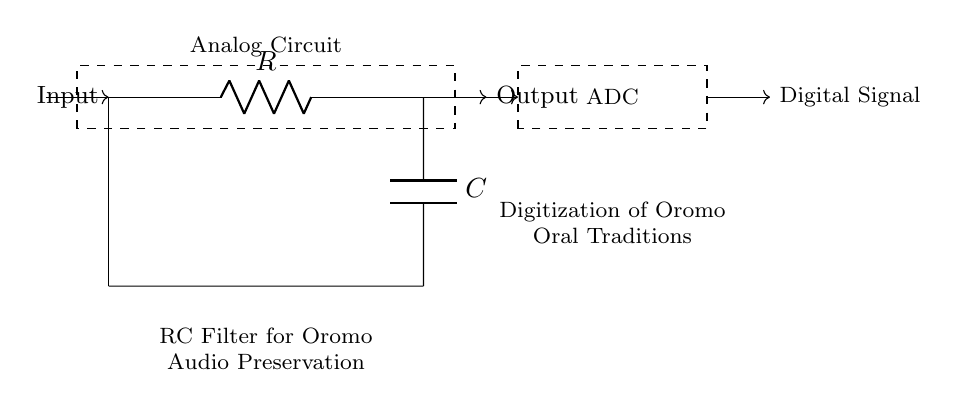What type of circuit is shown? The circuit is an analog RC filter, which consists of a resistor and a capacitor to process audio signals.
Answer: RC filter What does "R" represent in the circuit? "R" represents the resistor, which controls the current flow in the circuit.
Answer: Resistor What does "C" represent in the circuit? "C" represents the capacitor, which stores energy and influences the signal frequency response in the filter.
Answer: Capacitor What is the function of the RC filter? The function is to modify the audio signal for preservation and digitization, especially to enhance the desired frequency components while reducing others.
Answer: Modify audio signal How is the output taken from the circuit? The output is taken from the point connected to the capacitor, as it reflects the processed signal after the filtering action.
Answer: From the capacitor What does ADC stand for in this context? ADC stands for Analog-to-Digital Converter, which converts the analog audio signal from the RC filter into a digital signal for processing and storage.
Answer: Analog-to-Digital Converter What is the purpose of digitizing Oromo oral traditions? The purpose is to preserve the rich cultural heritage and ensure it can be accessed and shared in digital formats for future generations.
Answer: Cultural preservation 